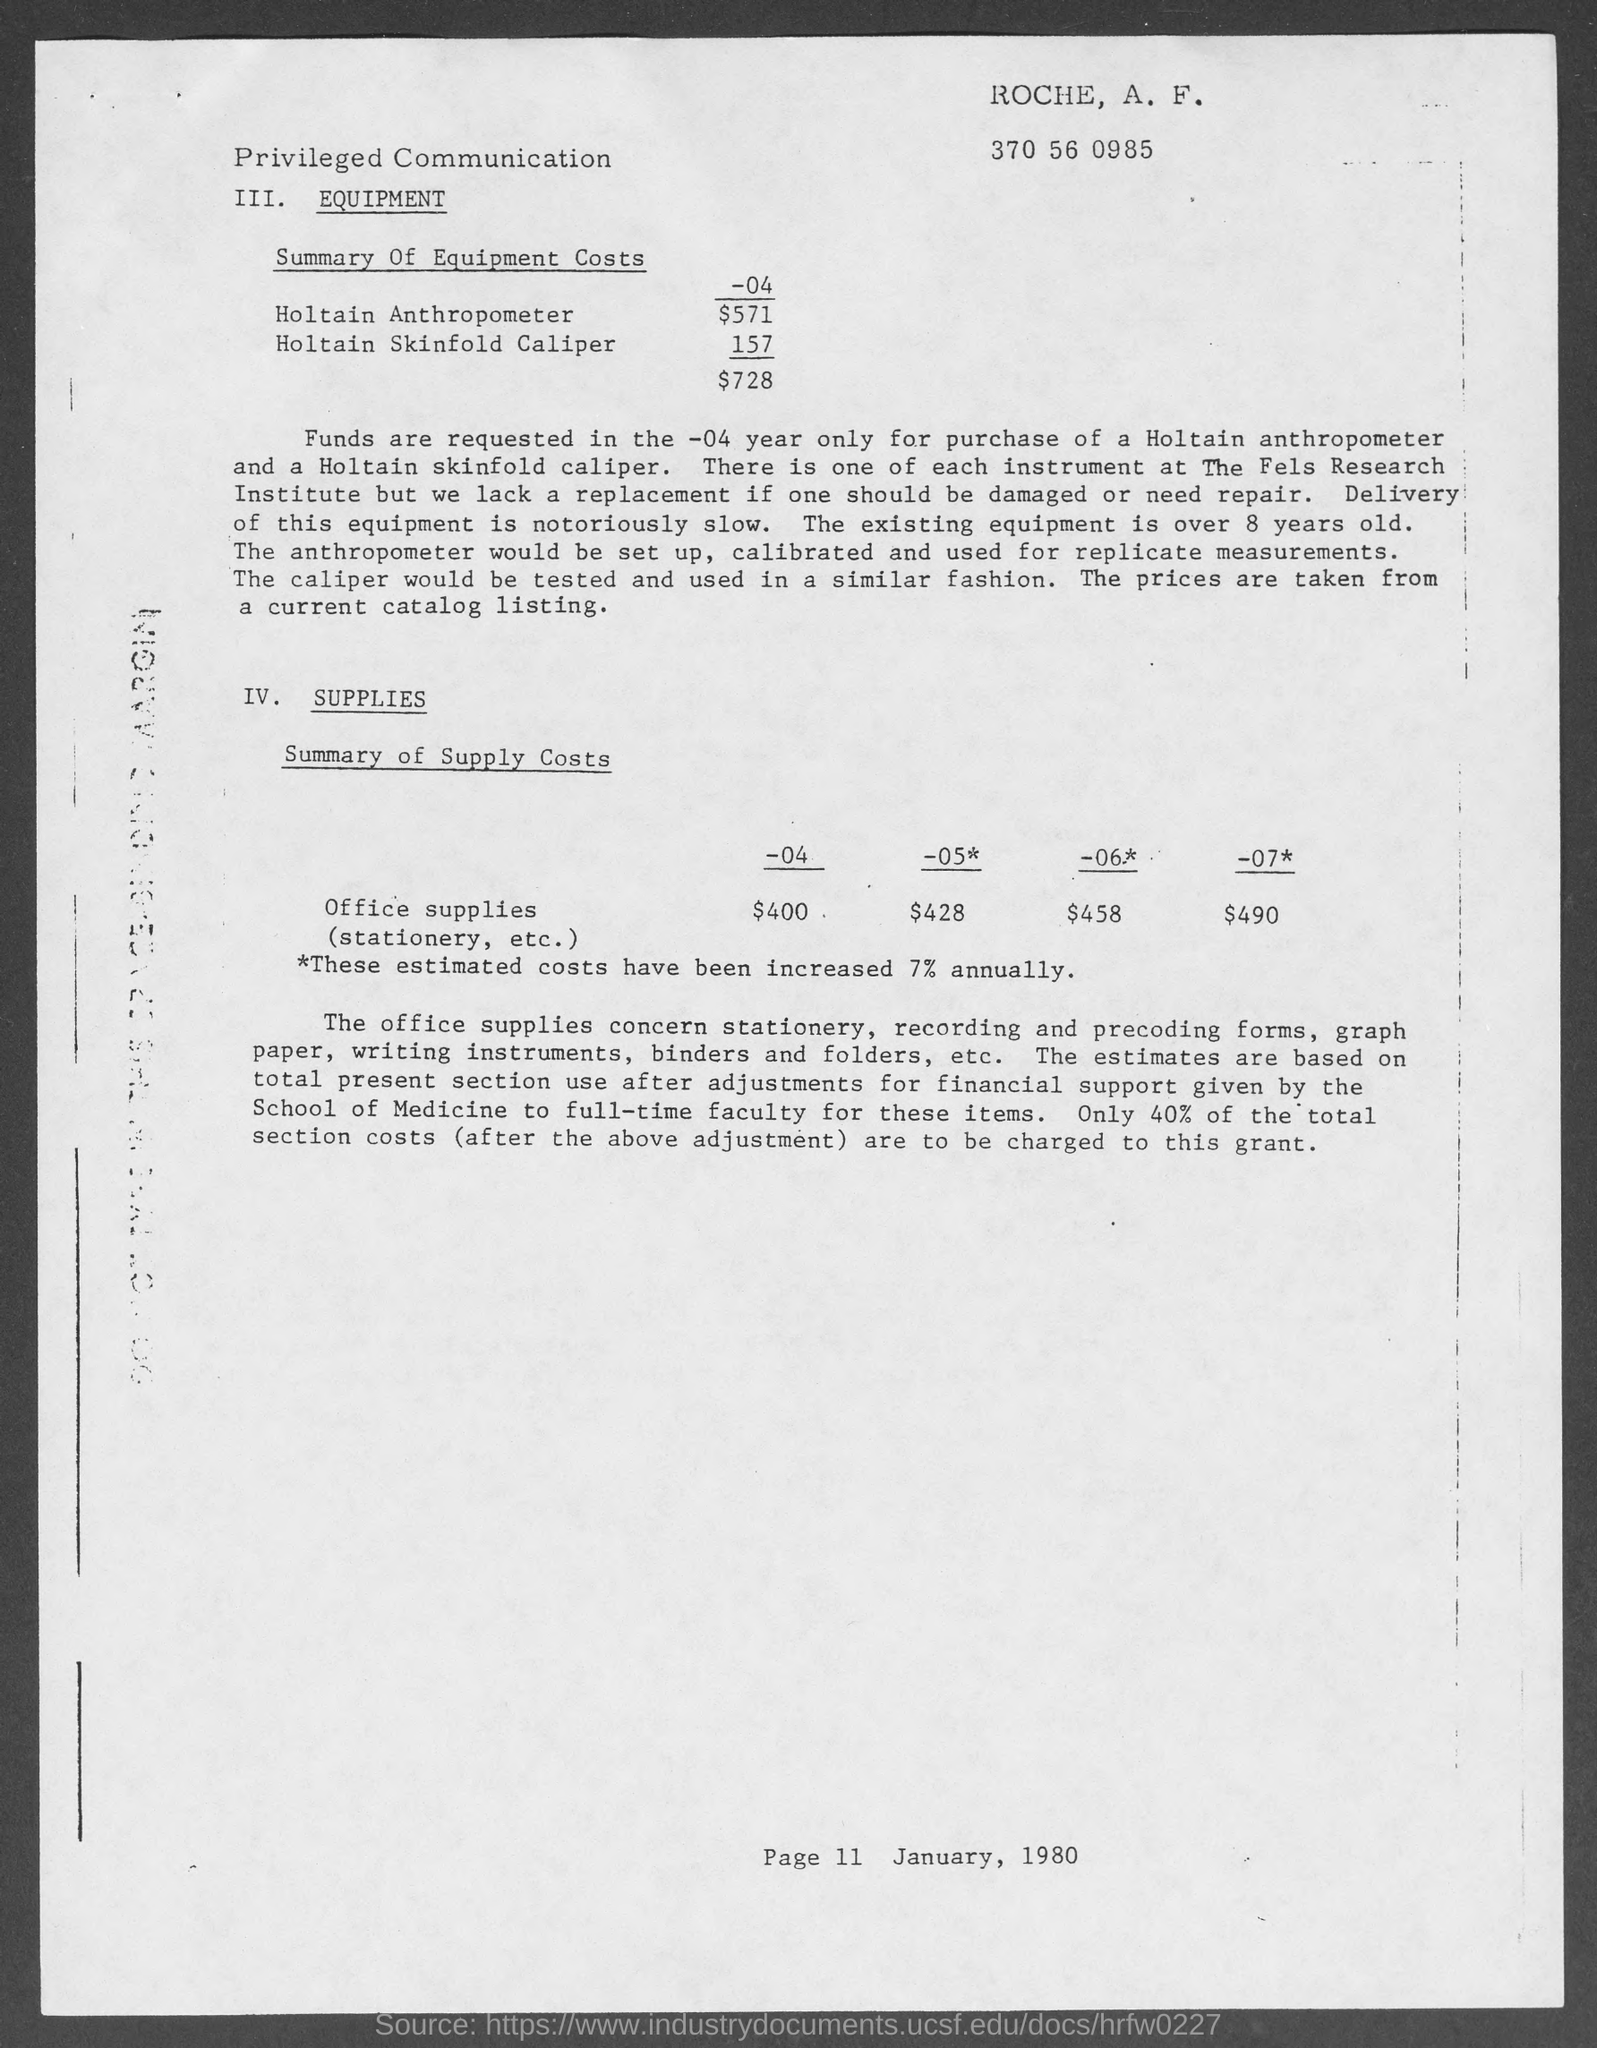What is the page no mentioned in this document?
Give a very brief answer. 11. What is the date mentioned in this document?
Provide a short and direct response. January, 1980. What is the equipment cost of Holtain Anthropometer for the year -04 ?
Ensure brevity in your answer.  $571. What is the summary of office supplies costs in the year -04?
Offer a terse response. $400. What is the summary of office supplies costs in the year -07*?
Make the answer very short. $490. What is the summary of office supplies costs in the year -05*?
Provide a succinct answer. $428. 